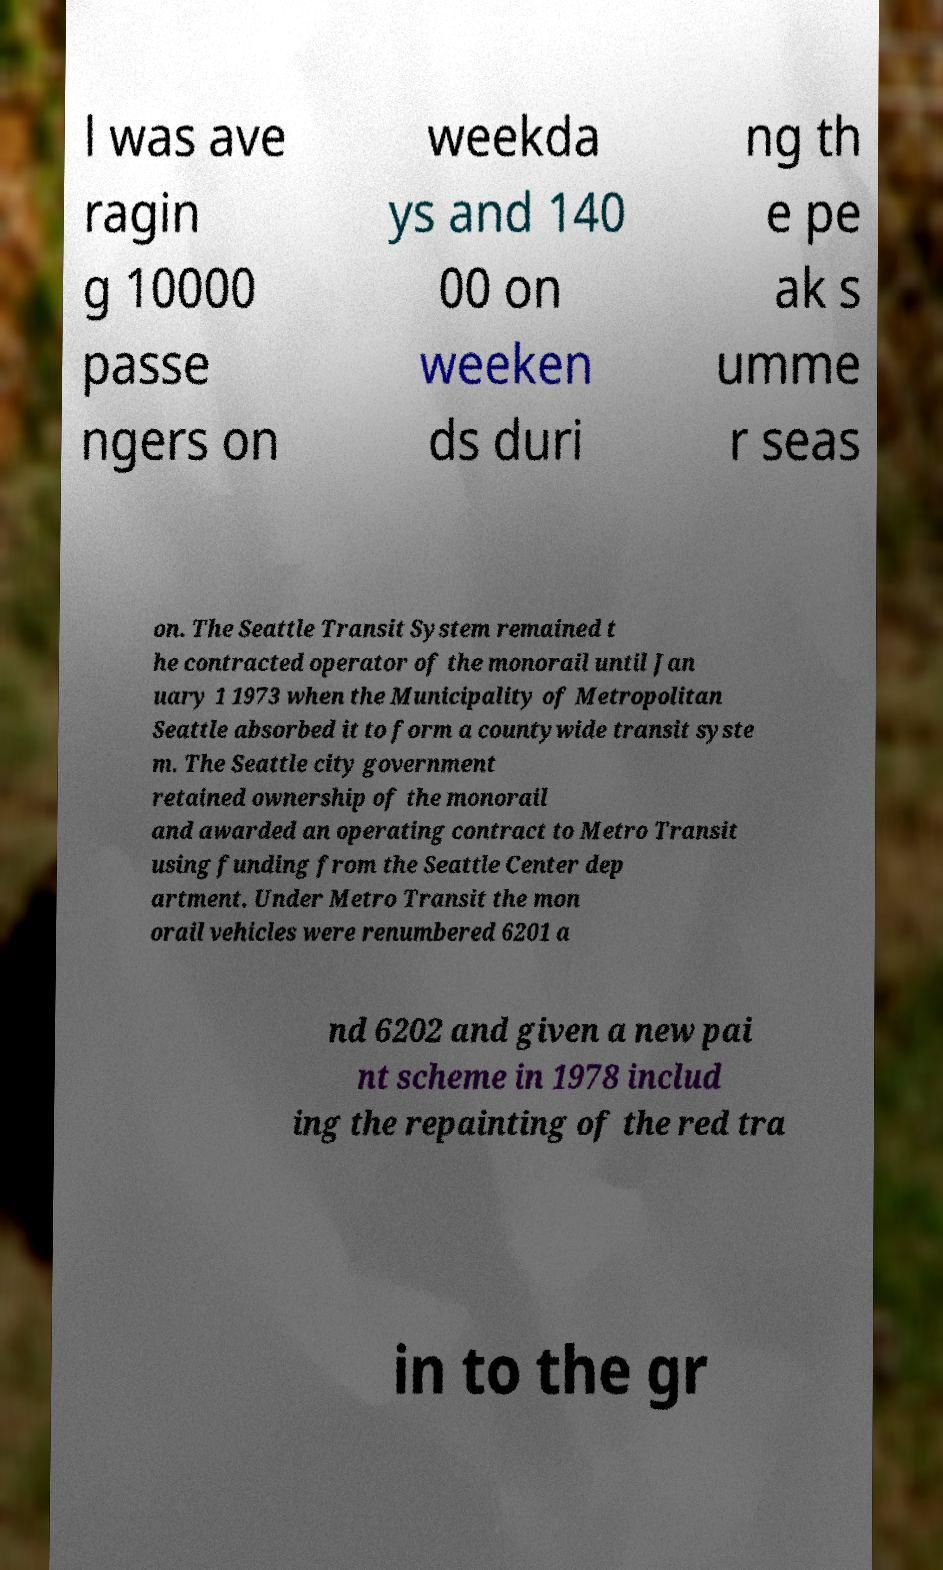Can you read and provide the text displayed in the image?This photo seems to have some interesting text. Can you extract and type it out for me? l was ave ragin g 10000 passe ngers on weekda ys and 140 00 on weeken ds duri ng th e pe ak s umme r seas on. The Seattle Transit System remained t he contracted operator of the monorail until Jan uary 1 1973 when the Municipality of Metropolitan Seattle absorbed it to form a countywide transit syste m. The Seattle city government retained ownership of the monorail and awarded an operating contract to Metro Transit using funding from the Seattle Center dep artment. Under Metro Transit the mon orail vehicles were renumbered 6201 a nd 6202 and given a new pai nt scheme in 1978 includ ing the repainting of the red tra in to the gr 